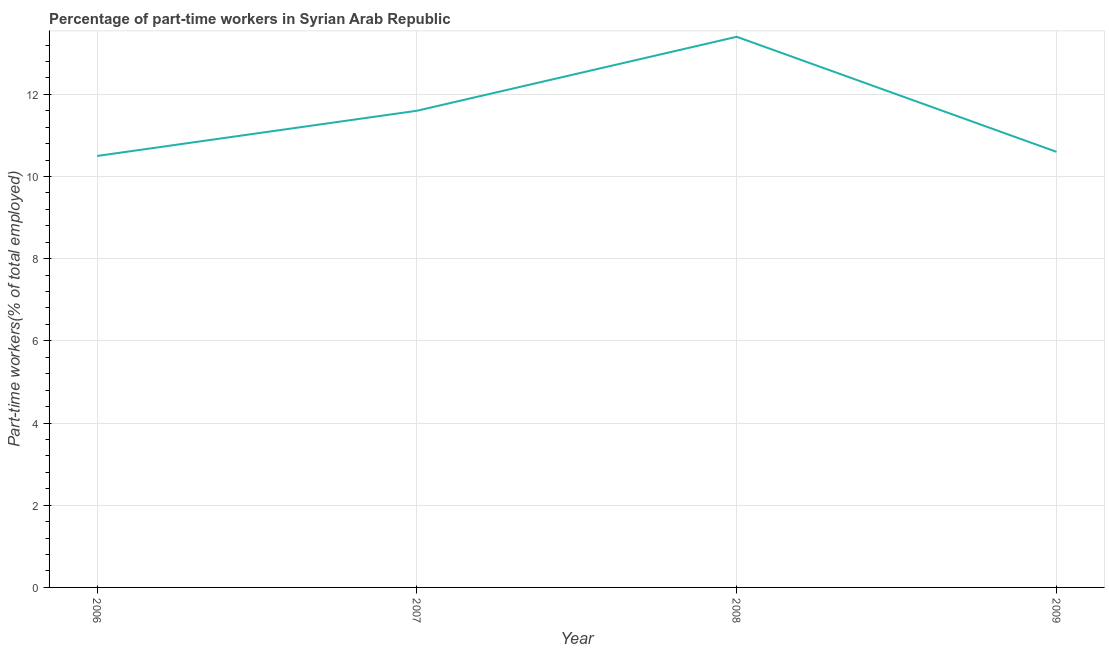What is the percentage of part-time workers in 2008?
Offer a very short reply. 13.4. Across all years, what is the maximum percentage of part-time workers?
Make the answer very short. 13.4. Across all years, what is the minimum percentage of part-time workers?
Offer a very short reply. 10.5. In which year was the percentage of part-time workers maximum?
Offer a terse response. 2008. What is the sum of the percentage of part-time workers?
Provide a short and direct response. 46.1. What is the difference between the percentage of part-time workers in 2006 and 2008?
Ensure brevity in your answer.  -2.9. What is the average percentage of part-time workers per year?
Give a very brief answer. 11.53. What is the median percentage of part-time workers?
Provide a short and direct response. 11.1. What is the ratio of the percentage of part-time workers in 2007 to that in 2008?
Make the answer very short. 0.87. Is the percentage of part-time workers in 2006 less than that in 2008?
Provide a succinct answer. Yes. Is the difference between the percentage of part-time workers in 2006 and 2008 greater than the difference between any two years?
Your response must be concise. Yes. What is the difference between the highest and the second highest percentage of part-time workers?
Offer a very short reply. 1.8. What is the difference between the highest and the lowest percentage of part-time workers?
Provide a succinct answer. 2.9. Does the percentage of part-time workers monotonically increase over the years?
Your answer should be very brief. No. How many years are there in the graph?
Provide a succinct answer. 4. What is the difference between two consecutive major ticks on the Y-axis?
Offer a very short reply. 2. Are the values on the major ticks of Y-axis written in scientific E-notation?
Offer a terse response. No. Does the graph contain grids?
Your answer should be very brief. Yes. What is the title of the graph?
Your answer should be compact. Percentage of part-time workers in Syrian Arab Republic. What is the label or title of the Y-axis?
Offer a very short reply. Part-time workers(% of total employed). What is the Part-time workers(% of total employed) in 2007?
Keep it short and to the point. 11.6. What is the Part-time workers(% of total employed) of 2008?
Offer a terse response. 13.4. What is the Part-time workers(% of total employed) of 2009?
Give a very brief answer. 10.6. What is the difference between the Part-time workers(% of total employed) in 2006 and 2008?
Provide a short and direct response. -2.9. What is the difference between the Part-time workers(% of total employed) in 2007 and 2008?
Offer a terse response. -1.8. What is the difference between the Part-time workers(% of total employed) in 2008 and 2009?
Your answer should be compact. 2.8. What is the ratio of the Part-time workers(% of total employed) in 2006 to that in 2007?
Make the answer very short. 0.91. What is the ratio of the Part-time workers(% of total employed) in 2006 to that in 2008?
Your response must be concise. 0.78. What is the ratio of the Part-time workers(% of total employed) in 2006 to that in 2009?
Make the answer very short. 0.99. What is the ratio of the Part-time workers(% of total employed) in 2007 to that in 2008?
Give a very brief answer. 0.87. What is the ratio of the Part-time workers(% of total employed) in 2007 to that in 2009?
Your response must be concise. 1.09. What is the ratio of the Part-time workers(% of total employed) in 2008 to that in 2009?
Ensure brevity in your answer.  1.26. 